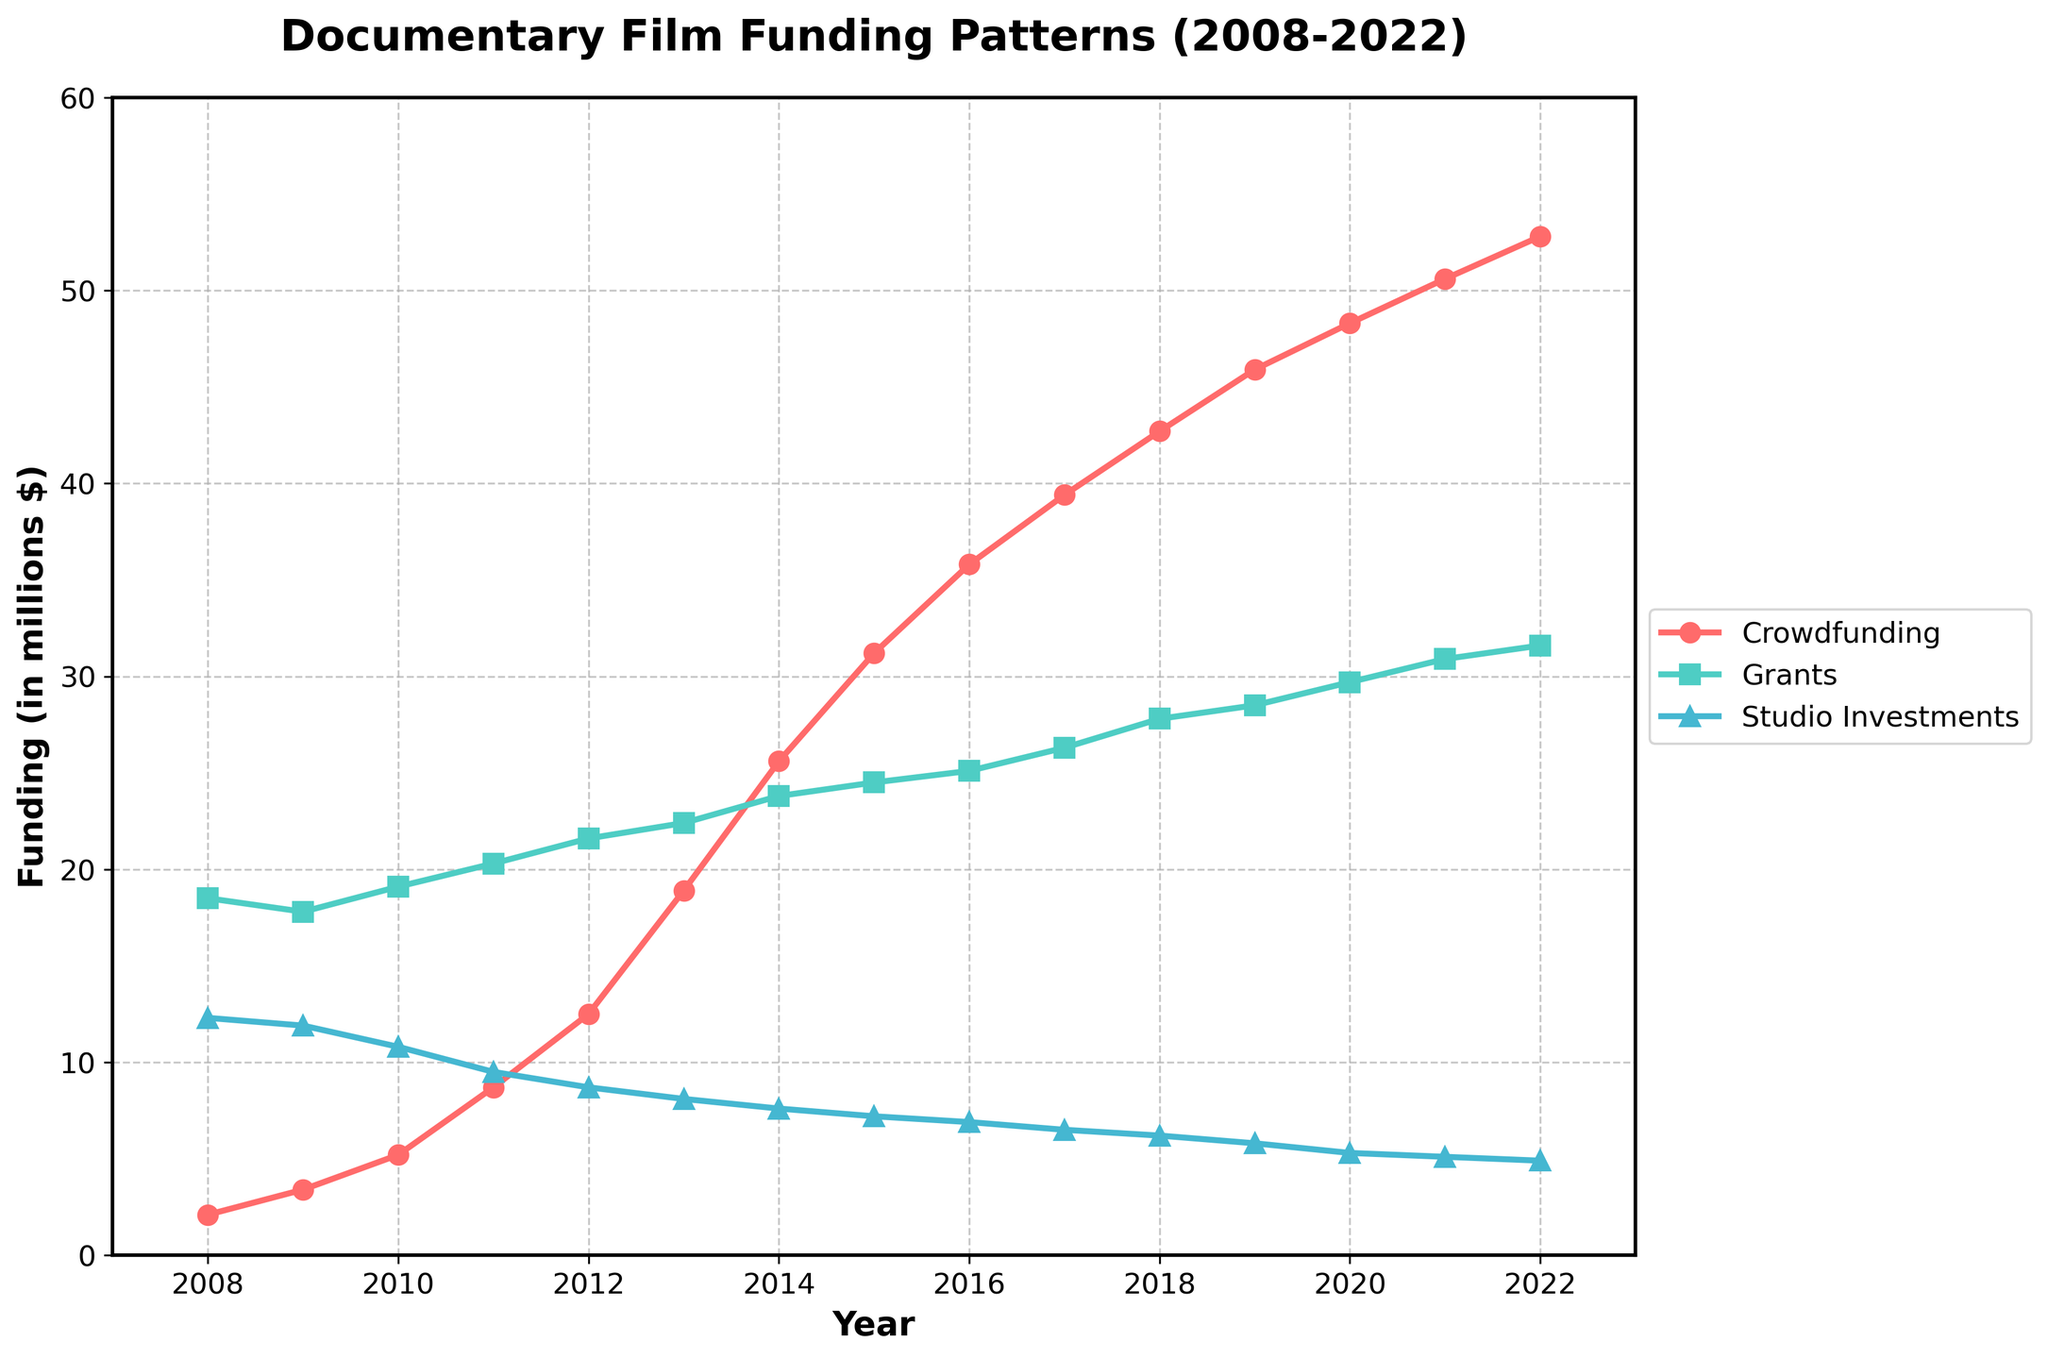What is the trend in studio investments over the last 15 years? By looking at the blue line with triangular markers (representing studio investments), it consistently declines from 12.3 million in 2008 to 4.9 million in 2022.
Answer: Declining In which year did grants funding surpass 25 million dollars? Observe the green line with square markers (representing grants); it crosses the 25 million dollar mark in 2016.
Answer: 2016 By how much did crowdfunding increase between 2008 and 2012? Crowdfunding in 2008 was 2.1 million and in 2012 was 12.5 million. The increase is calculated as 12.5 - 2.1.
Answer: 10.4 million Which funding source showed the largest growth over the 15 years and by how much? Crowdfunding increased from 2.1 million in 2008 to 52.8 million in 2022. The growth is 52.8 - 2.1. For grants, it grew from 18.5 to 31.6 (31.6 - 18.5). Studio investments decreased, so it is not considered.
Answer: Crowdfunding, 50.7 million In 2015, how does the crowdfunding amount compare to studio investments? In 2015, crowdfunding was 31.2 million, and studio investments were 7.2 million. Crowdfunding exceeds studio investments by 31.2 - 7.2.
Answer: 24 million more What is the overall trend in grants funding from 2008 to 2022? Visually following the green line with square markers (grants), it shows a consistent upward trend from 18.5 million in 2008 to 31.6 million in 2022.
Answer: Upward What is the average annual increase in crowdfunding from 2010 to 2015? Crowdfunding in 2010 was 5.2 million and in 2015 was 31.2 million. The increase over 5 years is 31.2 - 5.2, and the average annual increase is (31.2 - 5.2) / 5.
Answer: 5.2 million per year Which year did crowdfunding exceed grants for the first time? Crowdfunding first surpasses grants in 2020. Checking 2019 and 2020 shows: 45.9 million crowdfunding vs. 28.5 grants in 2019; 48.3 crowdfunding exceeds 29.7 grants in 2020.
Answer: 2020 How much more were grants compared to studio investments in 2021? In 2021, grants were 30.9 million, and studio investments were 5.1 million. The difference is 30.9 - 5.1.
Answer: 25.8 million What is the sum of the funding amounts for all three sources in 2010? Crowdfunding, grants, and studio investments in 2010 were 5.2 million, 19.1 million, and 10.8 million respectively. The sum is 5.2 + 19.1 + 10.8.
Answer: 35.1 million 